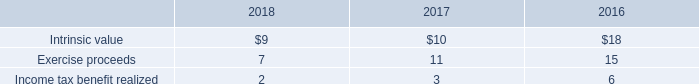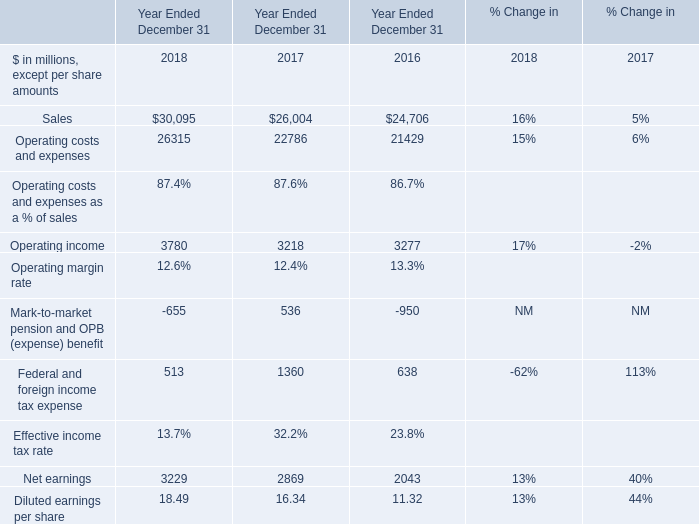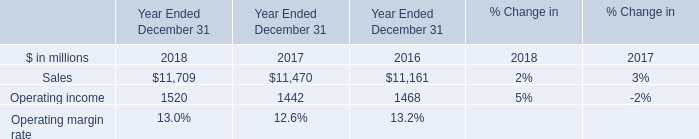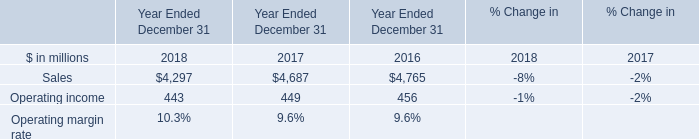If Operating income develops with the same growth rate as in 2017 Ended December 31,what will it reach in 2018 Ended December 31? (in million) 
Computations: (3218 * (1 + ((3218 - 3277) / 3277)))
Answer: 3160.06225. 